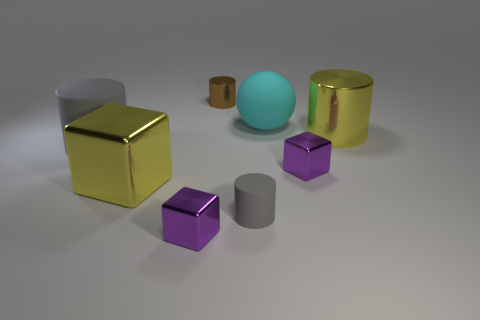Do the small rubber cylinder and the big metal cube have the same color?
Your response must be concise. No. There is a big thing that is the same color as the small matte object; what is its material?
Ensure brevity in your answer.  Rubber. Are there fewer large gray matte objects right of the big matte cylinder than cyan rubber objects that are behind the brown shiny cylinder?
Your answer should be very brief. No. Do the large cyan sphere and the big yellow block have the same material?
Provide a short and direct response. No. There is a cylinder that is left of the small matte object and in front of the large cyan object; what is its size?
Offer a terse response. Large. Are there an equal number of tiny brown metal objects and small yellow matte balls?
Your response must be concise. No. What is the shape of the gray thing that is the same size as the brown object?
Give a very brief answer. Cylinder. There is a gray cylinder that is in front of the small purple block right of the purple thing that is left of the brown thing; what is it made of?
Keep it short and to the point. Rubber. There is a gray thing on the left side of the tiny brown cylinder; is its shape the same as the small metallic object that is behind the large yellow cylinder?
Ensure brevity in your answer.  Yes. What number of other things are there of the same material as the big block
Provide a short and direct response. 4. 